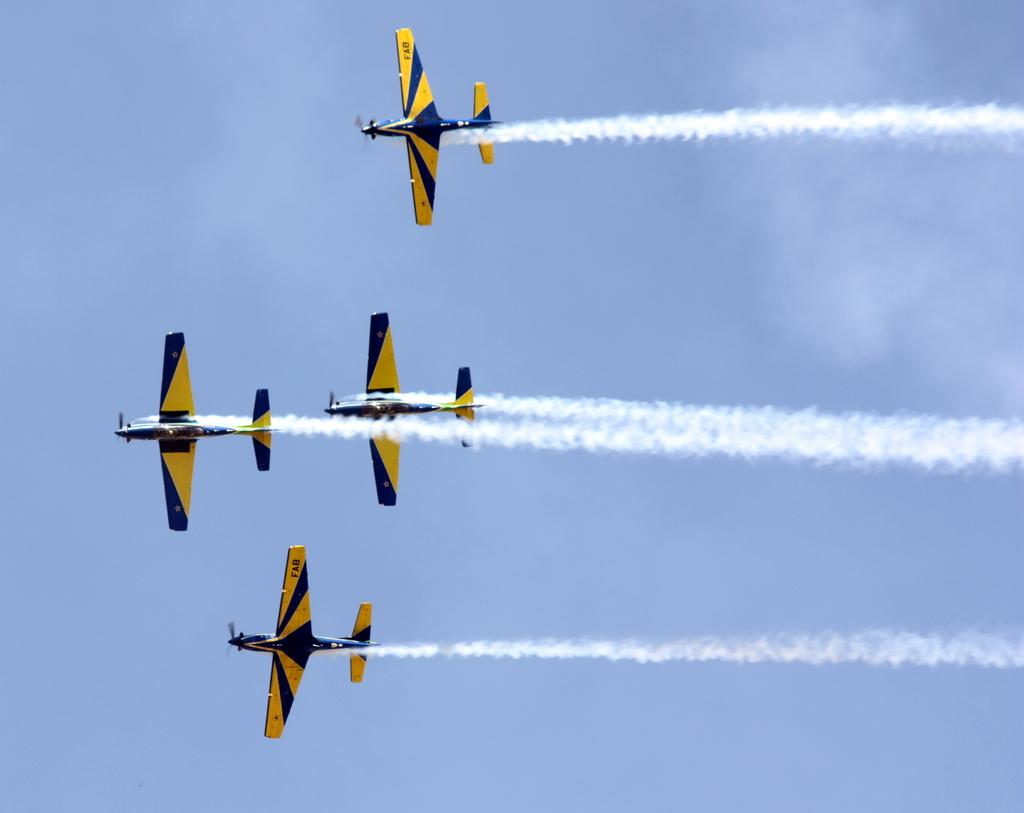What is the main subject of the image? The main subject of the image is aircrafts. What colors are the aircrafts in the image? The aircrafts are black and yellow in color. What are the aircrafts doing in the image? The aircrafts are flying in the sky. What else can be seen in the image besides the aircrafts? There is white smoke visible in the image. Are the aircrafts fighting with each other in the image? No, there is no indication in the image that the aircrafts are fighting with each other. 